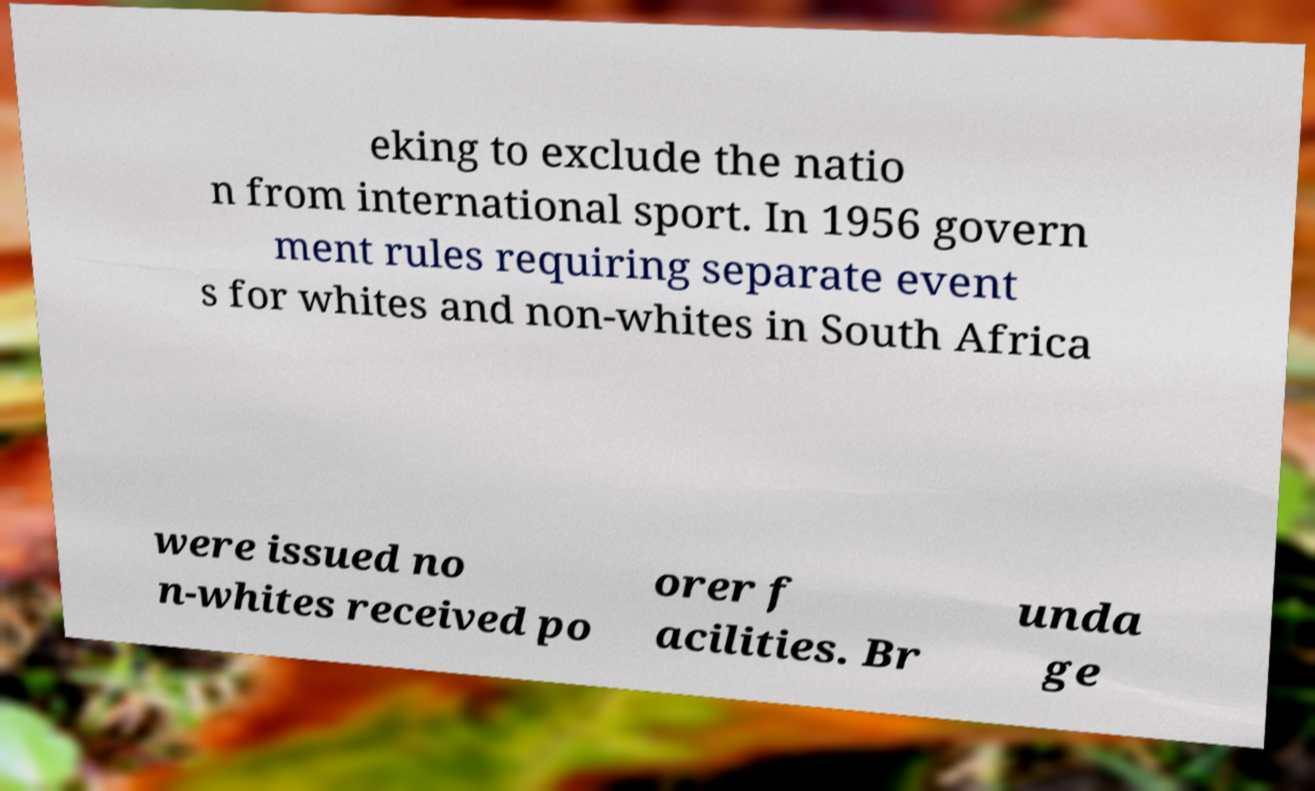Can you read and provide the text displayed in the image?This photo seems to have some interesting text. Can you extract and type it out for me? eking to exclude the natio n from international sport. In 1956 govern ment rules requiring separate event s for whites and non-whites in South Africa were issued no n-whites received po orer f acilities. Br unda ge 